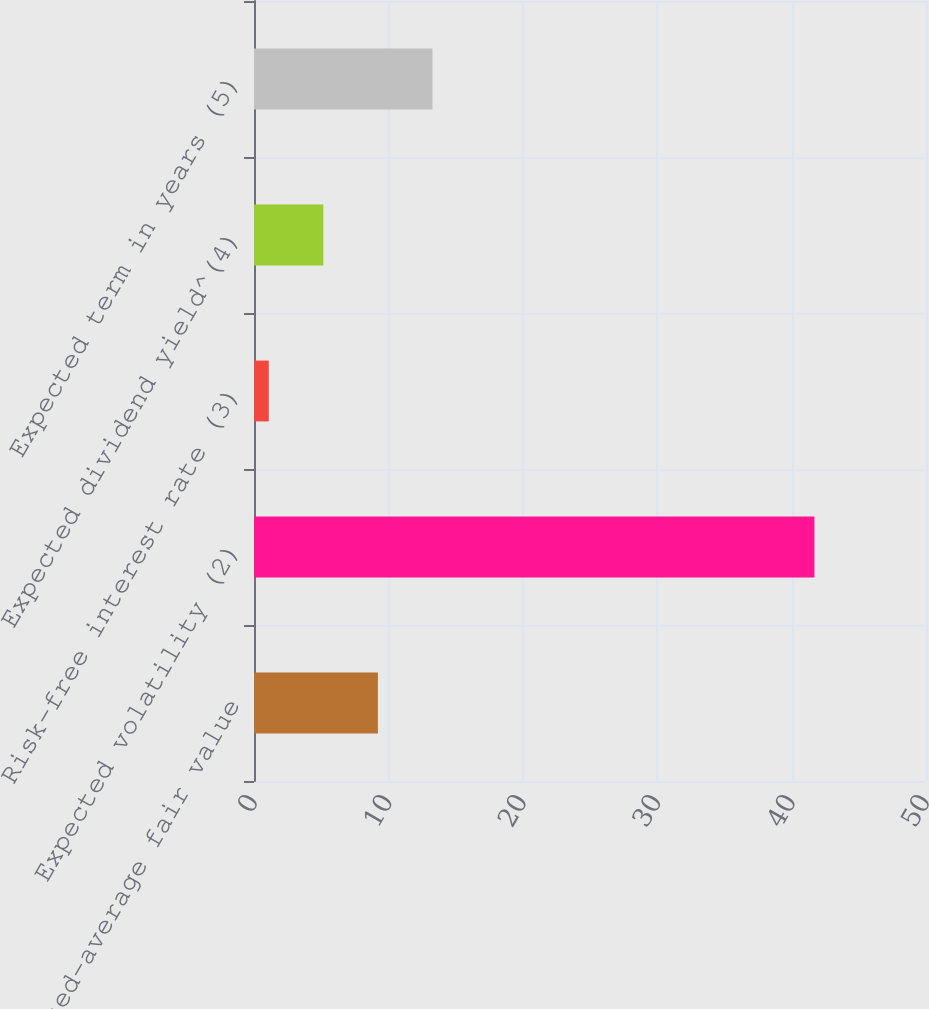Convert chart. <chart><loc_0><loc_0><loc_500><loc_500><bar_chart><fcel>Weighted-average fair value<fcel>Expected volatility (2)<fcel>Risk-free interest rate (3)<fcel>Expected dividend yield^(4)<fcel>Expected term in years (5)<nl><fcel>9.22<fcel>41.7<fcel>1.1<fcel>5.16<fcel>13.28<nl></chart> 